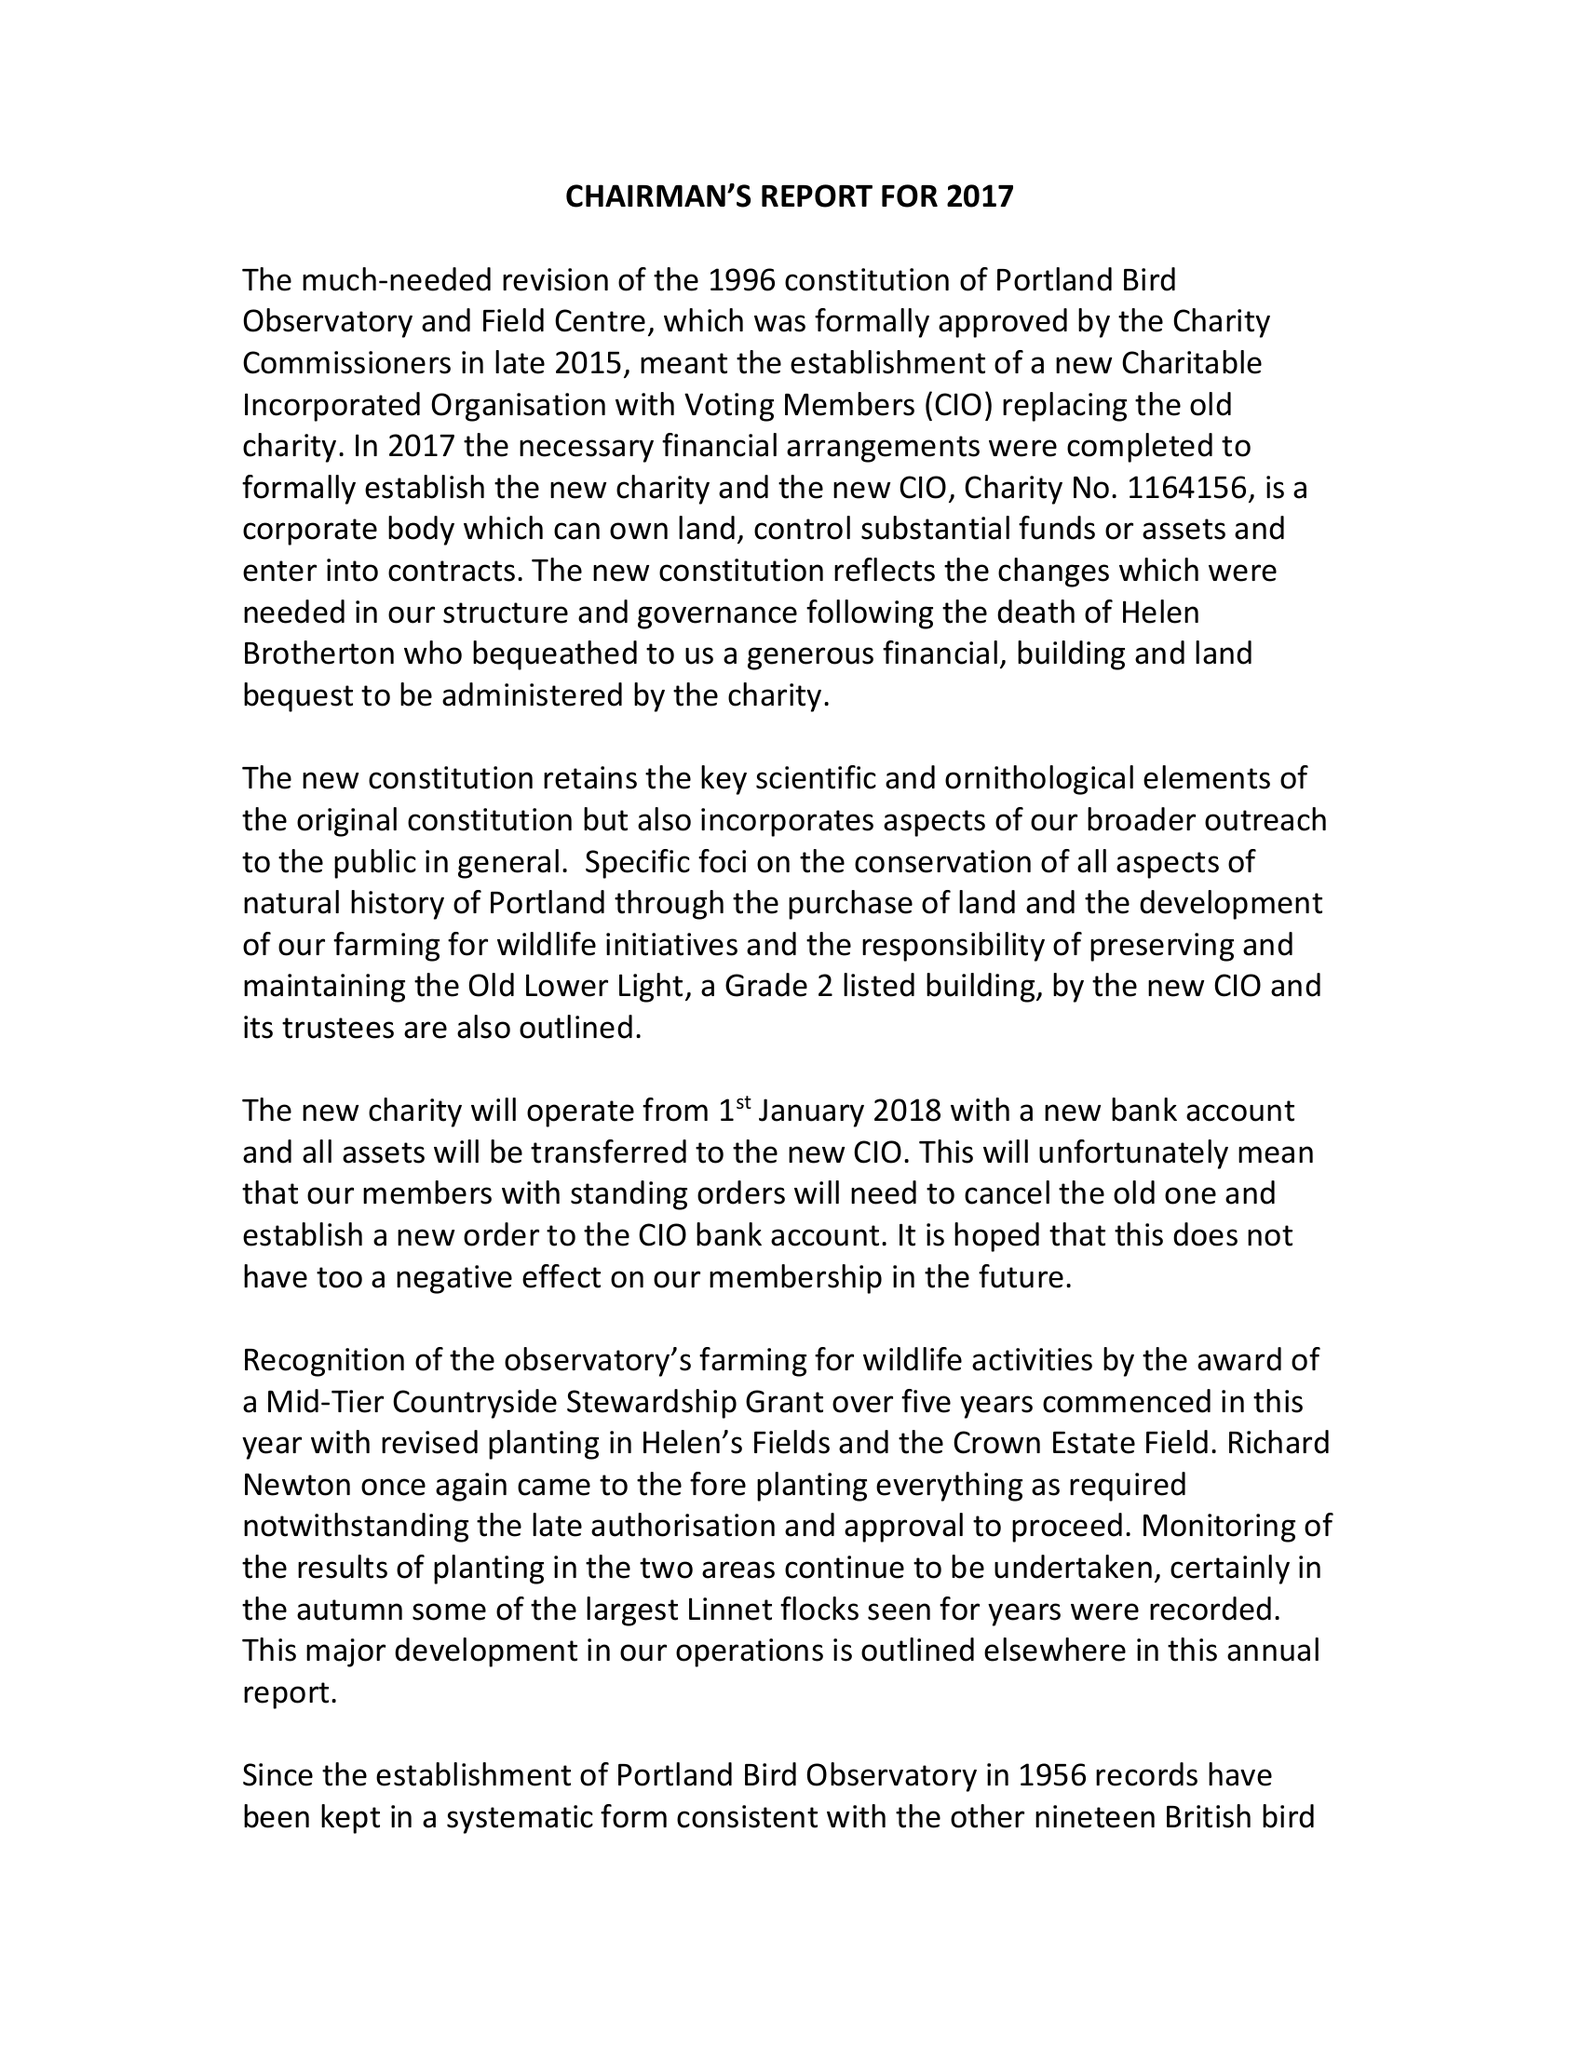What is the value for the charity_name?
Answer the question using a single word or phrase. Portland Bird Observatory and Field Centre 